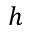Convert formula to latex. <formula><loc_0><loc_0><loc_500><loc_500>h</formula> 